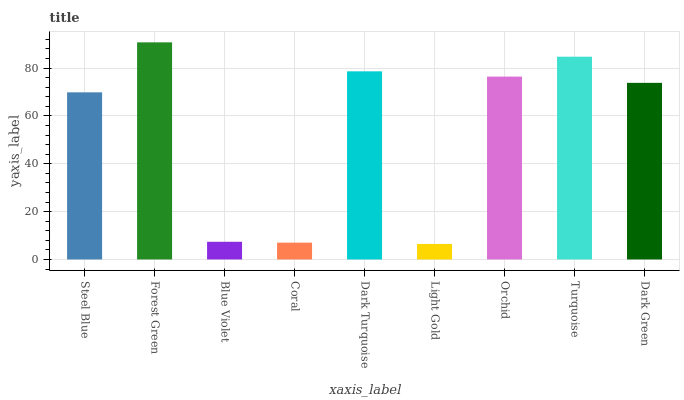Is Blue Violet the minimum?
Answer yes or no. No. Is Blue Violet the maximum?
Answer yes or no. No. Is Forest Green greater than Blue Violet?
Answer yes or no. Yes. Is Blue Violet less than Forest Green?
Answer yes or no. Yes. Is Blue Violet greater than Forest Green?
Answer yes or no. No. Is Forest Green less than Blue Violet?
Answer yes or no. No. Is Dark Green the high median?
Answer yes or no. Yes. Is Dark Green the low median?
Answer yes or no. Yes. Is Coral the high median?
Answer yes or no. No. Is Steel Blue the low median?
Answer yes or no. No. 